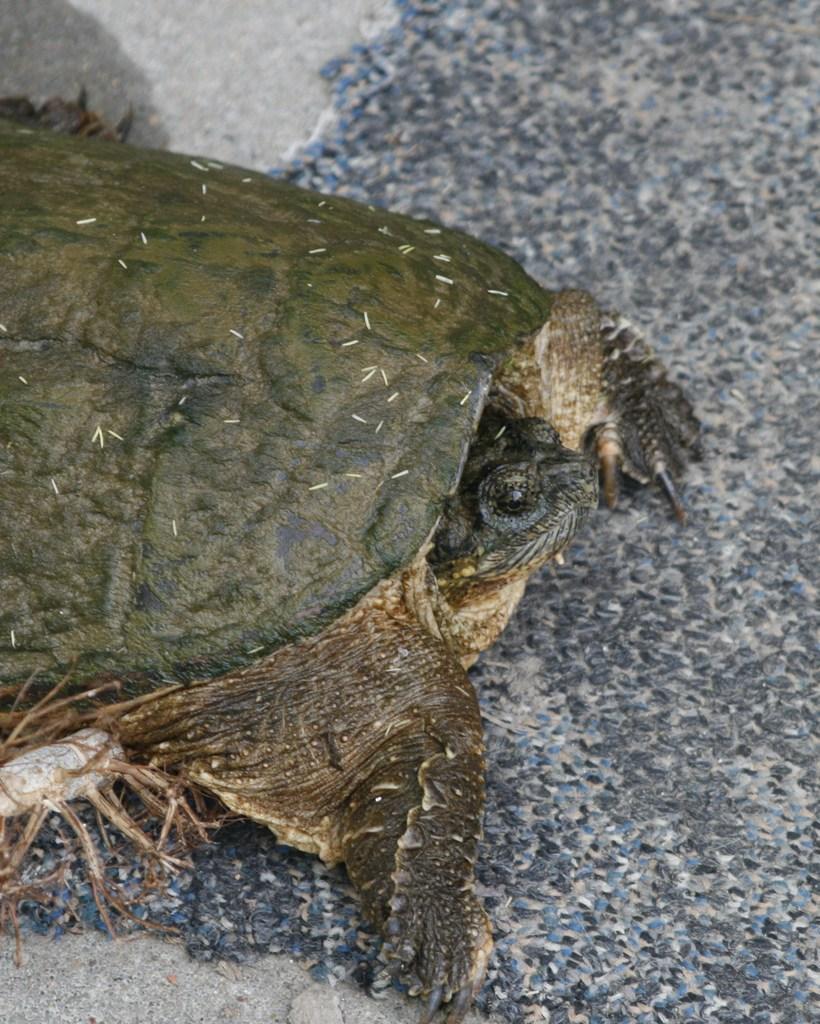Describe this image in one or two sentences. In this image we can see a turtle. 